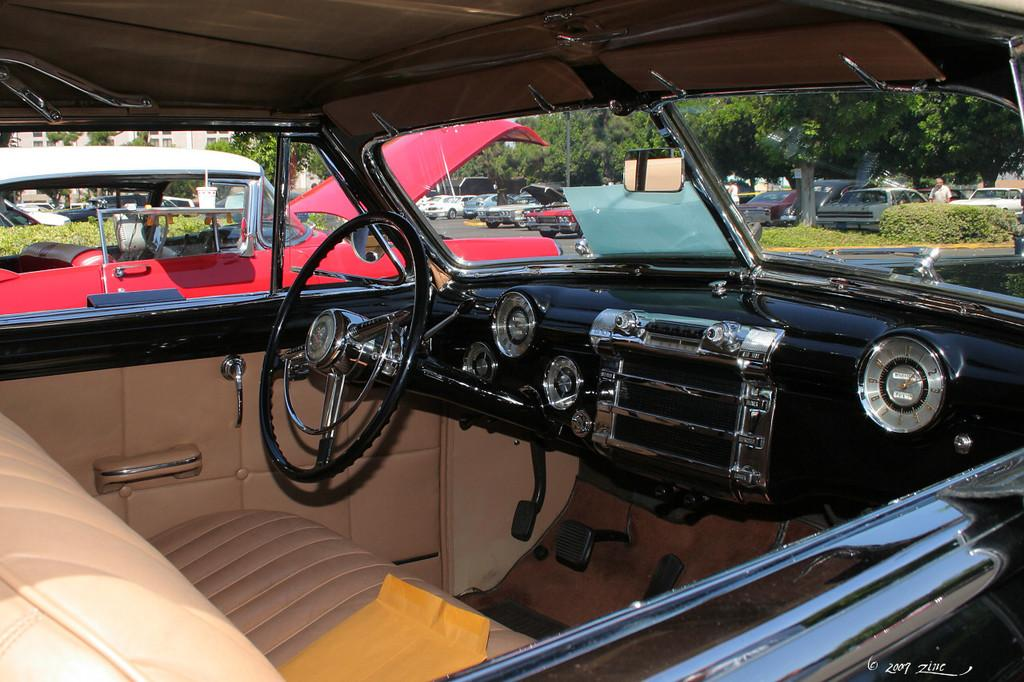What object can be seen in the image that is commonly associated with driving? There is a steering wheel in the image. What type of vehicles can be seen on the roads in the image? There are cars on the roads in the image. What type of structures are visible in the image? There are buildings visible in the image. What type of vegetation can be seen in the image? There are trees in the image. Can you describe the person in the image? There is a person standing in the image. What type of chess piece is sitting on the tray held by the queen in the image? There is no chess piece or queen present in the image. What type of food or drink might be served on the tray held by the queen in the image? There is no tray or queen present in the image, so it is not possible to determine what might be served on a tray. 